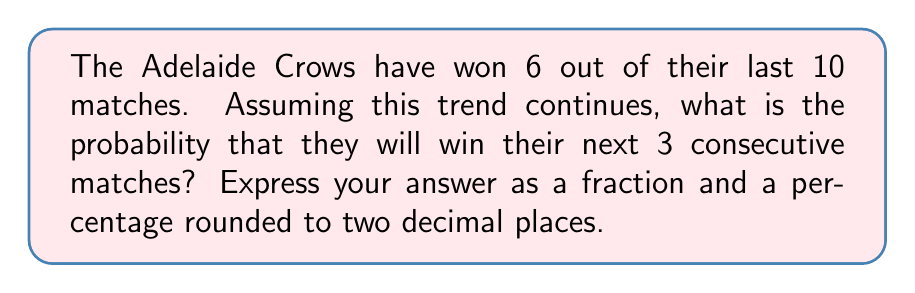Could you help me with this problem? Let's approach this step-by-step:

1) First, we need to calculate the probability of winning a single match. Based on the given data:

   $P(\text{win}) = \frac{\text{number of wins}}{\text{total matches}} = \frac{6}{10} = 0.6$

2) Now, we need to calculate the probability of winning 3 consecutive matches. Since each match is independent, we can use the multiplication rule of probability:

   $P(\text{3 consecutive wins}) = P(\text{win}) \times P(\text{win}) \times P(\text{win})$

3) Substituting our value:

   $P(\text{3 consecutive wins}) = 0.6 \times 0.6 \times 0.6 = 0.6^3$

4) Let's calculate this:

   $0.6^3 = 0.216$

5) To express this as a fraction, we can write:

   $\frac{216}{1000} = \frac{27}{125}$

6) To express as a percentage rounded to two decimal places:

   $0.216 \times 100 = 21.60\%$
Answer: $\frac{27}{125}$ or $21.60\%$ 